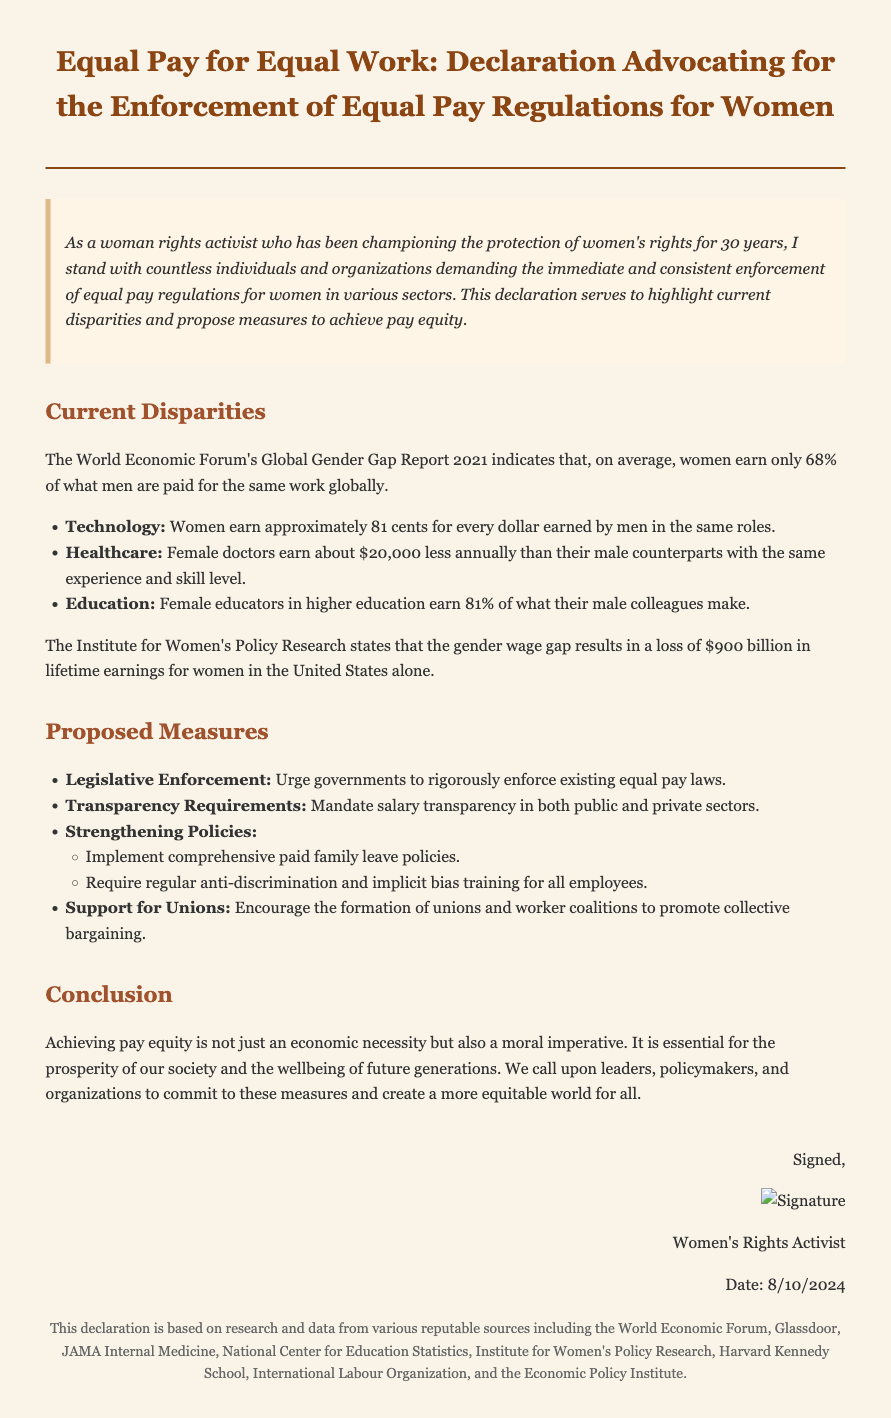What is the global average percentage of what women earn compared to men? The document mentions that, on average, women earn only 68% of what men are paid for the same work globally.
Answer: 68% In which sector do women earn approximately 81 cents for every dollar earned by men? The document states that this is specific to the Technology sector.
Answer: Technology How much less do female doctors earn annually compared to their male counterparts? The document indicates that female doctors earn about $20,000 less annually than male doctors with the same experience and skill level.
Answer: $20,000 What is one proposed measure to enforce equal pay laws? The document lists "Legislative Enforcement" as one of the proposed measures to urge governments to rigorously enforce existing equal pay laws.
Answer: Legislative Enforcement What is the estimated loss in lifetime earnings for women in the United States due to the gender wage gap? According to the document, the estimated loss is $900 billion in lifetime earnings for women in the United States.
Answer: $900 billion What are the two types of training required according to the proposed measures? The document specifies that regular anti-discrimination and implicit bias training for all employees should be required.
Answer: Anti-discrimination and implicit bias training Who is the author of the declaration? The document identifies the author as a "Women's Rights Activist."
Answer: Women's Rights Activist What moral imperative is emphasized in the conclusion of the document? The document states that achieving pay equity is described as a moral imperative.
Answer: Moral imperative 